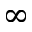<formula> <loc_0><loc_0><loc_500><loc_500>\infty</formula> 